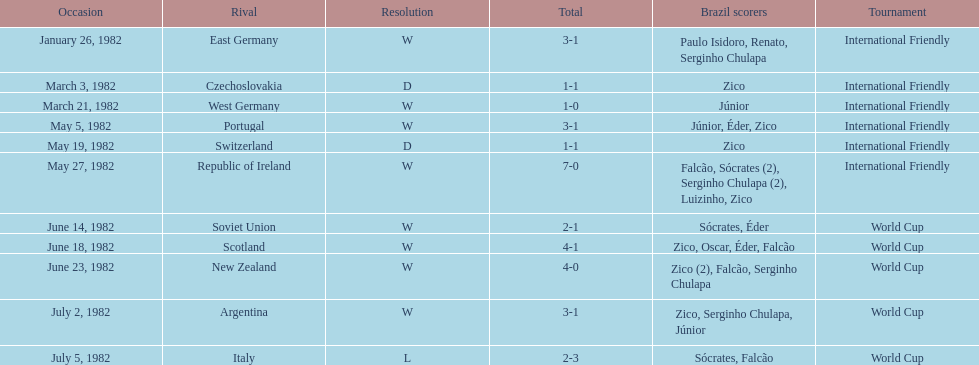Who was this team's next opponent after facing the soviet union on june 14? Scotland. 